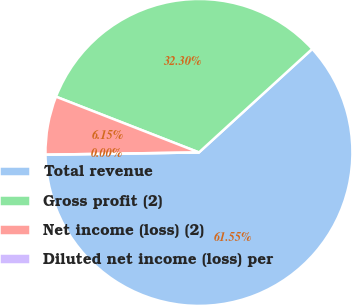Convert chart. <chart><loc_0><loc_0><loc_500><loc_500><pie_chart><fcel>Total revenue<fcel>Gross profit (2)<fcel>Net income (loss) (2)<fcel>Diluted net income (loss) per<nl><fcel>61.55%<fcel>32.3%<fcel>6.15%<fcel>0.0%<nl></chart> 